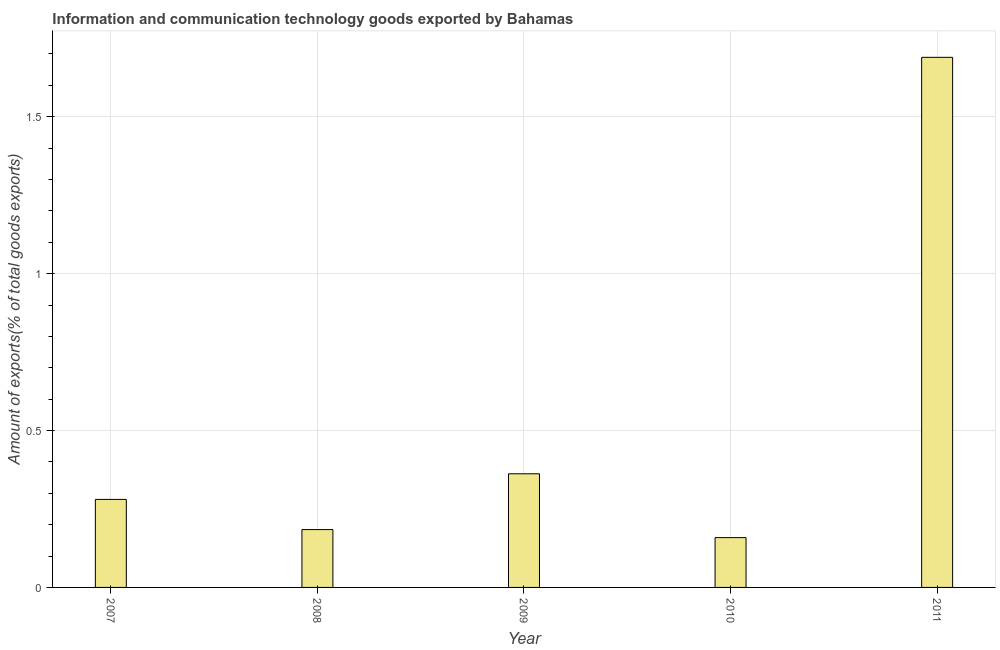What is the title of the graph?
Your answer should be very brief. Information and communication technology goods exported by Bahamas. What is the label or title of the Y-axis?
Your answer should be compact. Amount of exports(% of total goods exports). What is the amount of ict goods exports in 2011?
Ensure brevity in your answer.  1.69. Across all years, what is the maximum amount of ict goods exports?
Offer a terse response. 1.69. Across all years, what is the minimum amount of ict goods exports?
Your answer should be very brief. 0.16. In which year was the amount of ict goods exports maximum?
Your answer should be very brief. 2011. What is the sum of the amount of ict goods exports?
Offer a very short reply. 2.67. What is the difference between the amount of ict goods exports in 2008 and 2010?
Your answer should be compact. 0.03. What is the average amount of ict goods exports per year?
Give a very brief answer. 0.54. What is the median amount of ict goods exports?
Your answer should be very brief. 0.28. What is the ratio of the amount of ict goods exports in 2007 to that in 2011?
Provide a short and direct response. 0.17. What is the difference between the highest and the second highest amount of ict goods exports?
Offer a very short reply. 1.33. Is the sum of the amount of ict goods exports in 2007 and 2009 greater than the maximum amount of ict goods exports across all years?
Give a very brief answer. No. What is the difference between the highest and the lowest amount of ict goods exports?
Make the answer very short. 1.53. How many years are there in the graph?
Keep it short and to the point. 5. What is the Amount of exports(% of total goods exports) in 2007?
Your answer should be compact. 0.28. What is the Amount of exports(% of total goods exports) in 2008?
Your response must be concise. 0.18. What is the Amount of exports(% of total goods exports) in 2009?
Keep it short and to the point. 0.36. What is the Amount of exports(% of total goods exports) in 2010?
Offer a very short reply. 0.16. What is the Amount of exports(% of total goods exports) in 2011?
Your response must be concise. 1.69. What is the difference between the Amount of exports(% of total goods exports) in 2007 and 2008?
Give a very brief answer. 0.1. What is the difference between the Amount of exports(% of total goods exports) in 2007 and 2009?
Provide a succinct answer. -0.08. What is the difference between the Amount of exports(% of total goods exports) in 2007 and 2010?
Ensure brevity in your answer.  0.12. What is the difference between the Amount of exports(% of total goods exports) in 2007 and 2011?
Your response must be concise. -1.41. What is the difference between the Amount of exports(% of total goods exports) in 2008 and 2009?
Your answer should be compact. -0.18. What is the difference between the Amount of exports(% of total goods exports) in 2008 and 2010?
Ensure brevity in your answer.  0.03. What is the difference between the Amount of exports(% of total goods exports) in 2008 and 2011?
Your answer should be compact. -1.5. What is the difference between the Amount of exports(% of total goods exports) in 2009 and 2010?
Offer a terse response. 0.2. What is the difference between the Amount of exports(% of total goods exports) in 2009 and 2011?
Your response must be concise. -1.33. What is the difference between the Amount of exports(% of total goods exports) in 2010 and 2011?
Offer a very short reply. -1.53. What is the ratio of the Amount of exports(% of total goods exports) in 2007 to that in 2008?
Offer a very short reply. 1.52. What is the ratio of the Amount of exports(% of total goods exports) in 2007 to that in 2009?
Your answer should be very brief. 0.77. What is the ratio of the Amount of exports(% of total goods exports) in 2007 to that in 2010?
Your answer should be compact. 1.77. What is the ratio of the Amount of exports(% of total goods exports) in 2007 to that in 2011?
Your answer should be compact. 0.17. What is the ratio of the Amount of exports(% of total goods exports) in 2008 to that in 2009?
Provide a succinct answer. 0.51. What is the ratio of the Amount of exports(% of total goods exports) in 2008 to that in 2010?
Ensure brevity in your answer.  1.16. What is the ratio of the Amount of exports(% of total goods exports) in 2008 to that in 2011?
Your response must be concise. 0.11. What is the ratio of the Amount of exports(% of total goods exports) in 2009 to that in 2010?
Your answer should be very brief. 2.28. What is the ratio of the Amount of exports(% of total goods exports) in 2009 to that in 2011?
Provide a succinct answer. 0.21. What is the ratio of the Amount of exports(% of total goods exports) in 2010 to that in 2011?
Offer a very short reply. 0.09. 